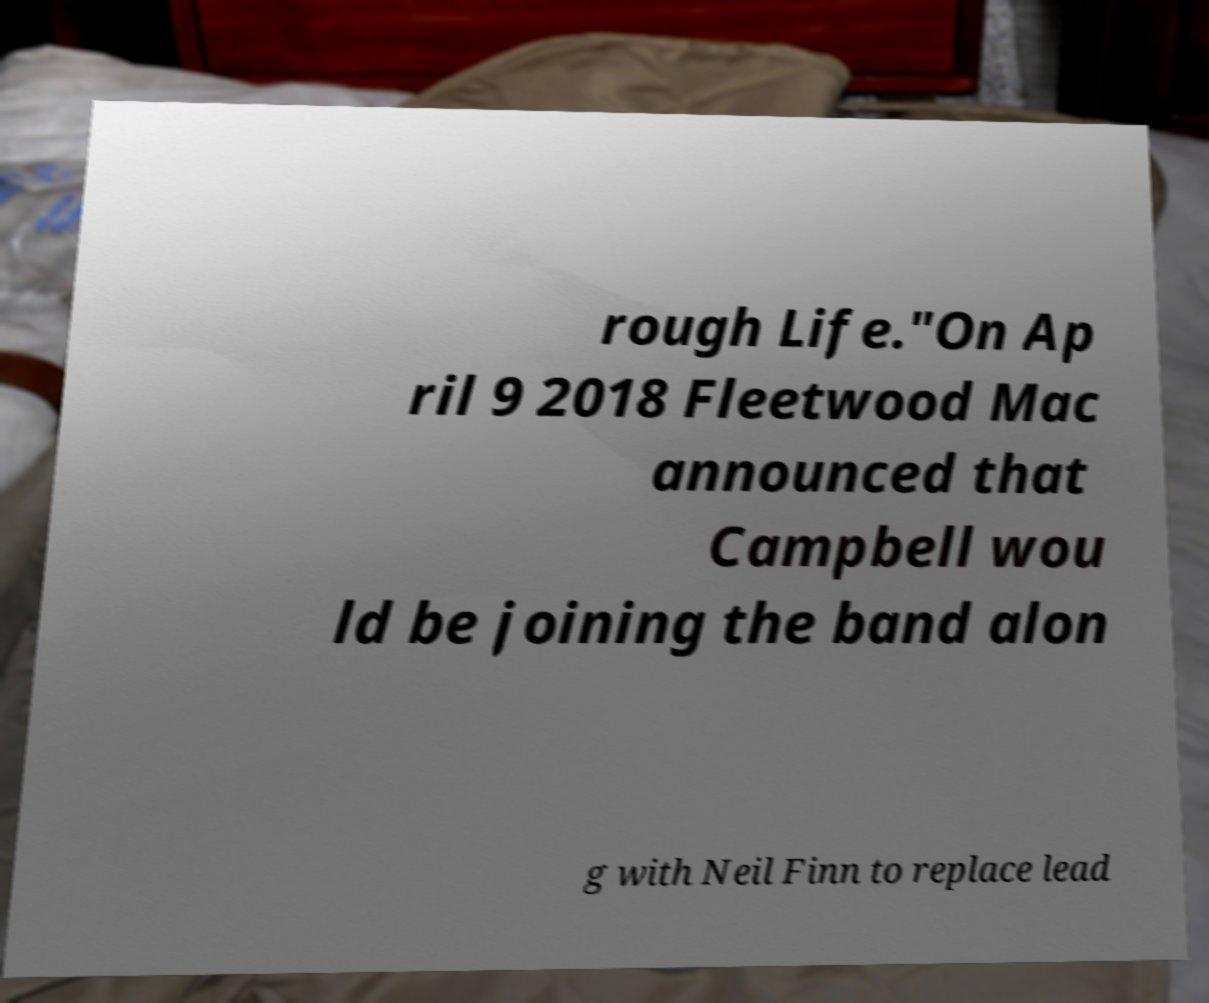I need the written content from this picture converted into text. Can you do that? rough Life."On Ap ril 9 2018 Fleetwood Mac announced that Campbell wou ld be joining the band alon g with Neil Finn to replace lead 